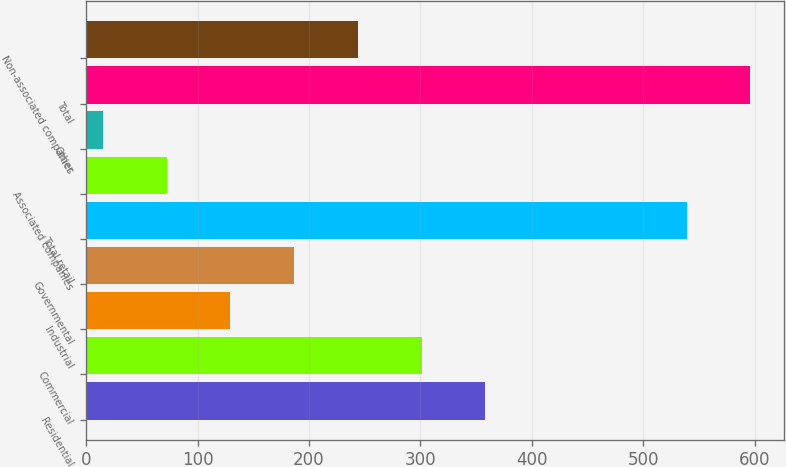Convert chart. <chart><loc_0><loc_0><loc_500><loc_500><bar_chart><fcel>Residential<fcel>Commercial<fcel>Industrial<fcel>Governmental<fcel>Total retail<fcel>Associated companies<fcel>Other<fcel>Total<fcel>Non-associated companies<nl><fcel>358.2<fcel>301<fcel>129.4<fcel>186.6<fcel>539<fcel>72.2<fcel>15<fcel>596.2<fcel>243.8<nl></chart> 